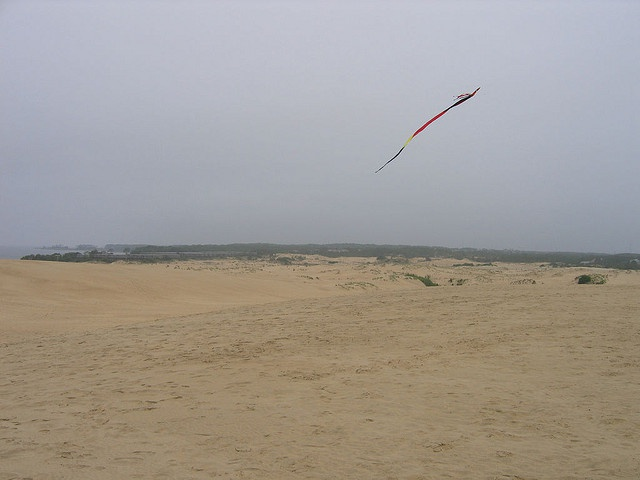Describe the objects in this image and their specific colors. I can see a kite in darkgray, black, brown, and lightgray tones in this image. 